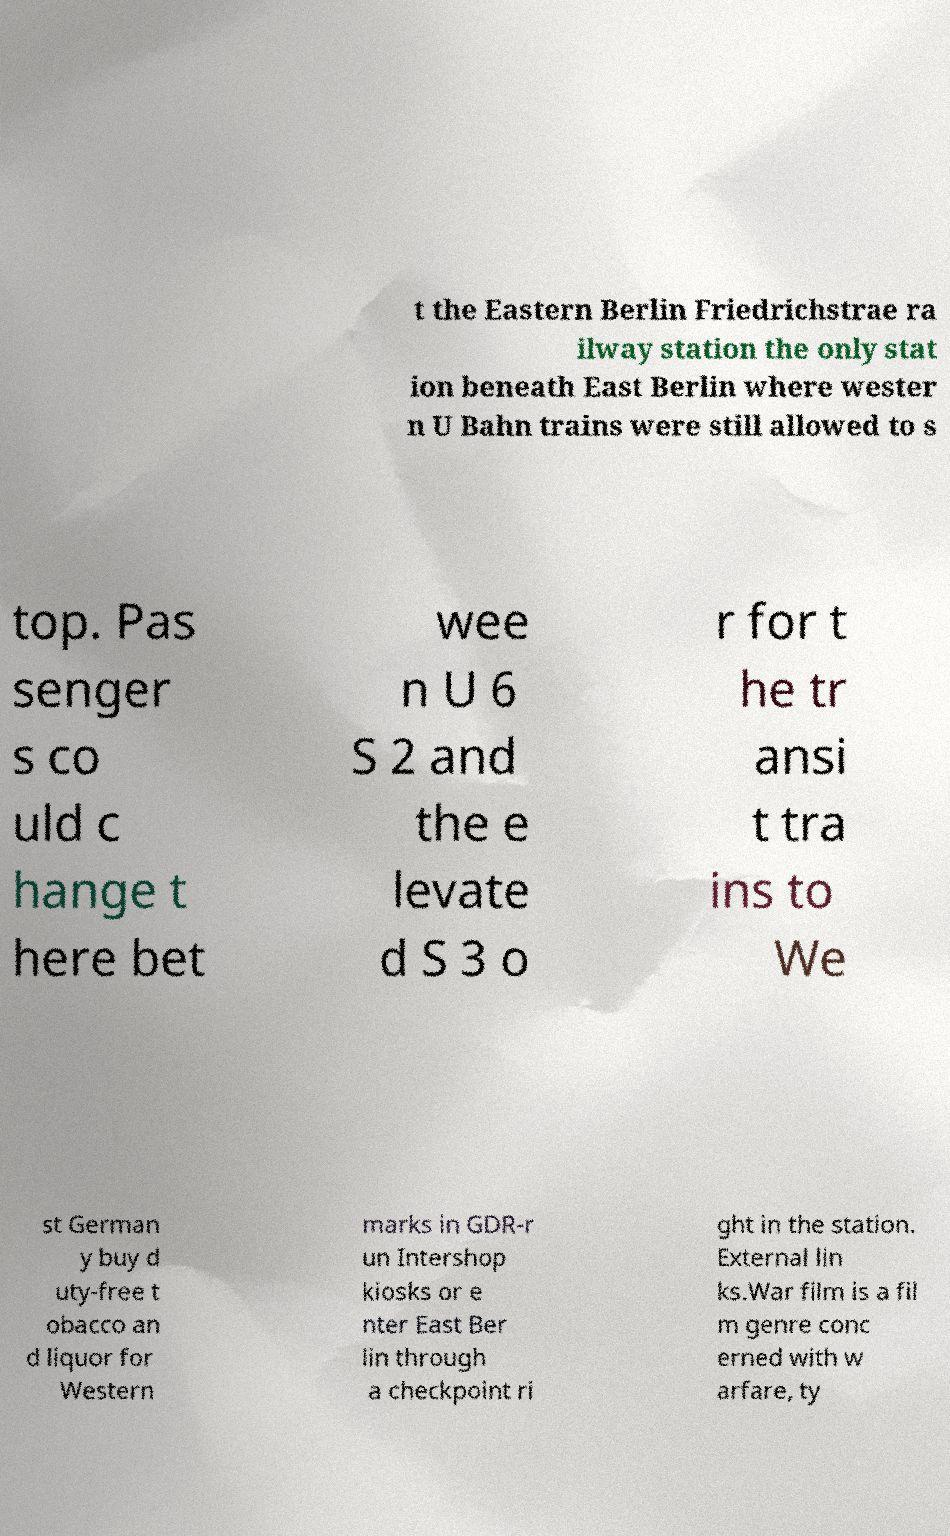There's text embedded in this image that I need extracted. Can you transcribe it verbatim? t the Eastern Berlin Friedrichstrae ra ilway station the only stat ion beneath East Berlin where wester n U Bahn trains were still allowed to s top. Pas senger s co uld c hange t here bet wee n U 6 S 2 and the e levate d S 3 o r for t he tr ansi t tra ins to We st German y buy d uty-free t obacco an d liquor for Western marks in GDR-r un Intershop kiosks or e nter East Ber lin through a checkpoint ri ght in the station. External lin ks.War film is a fil m genre conc erned with w arfare, ty 